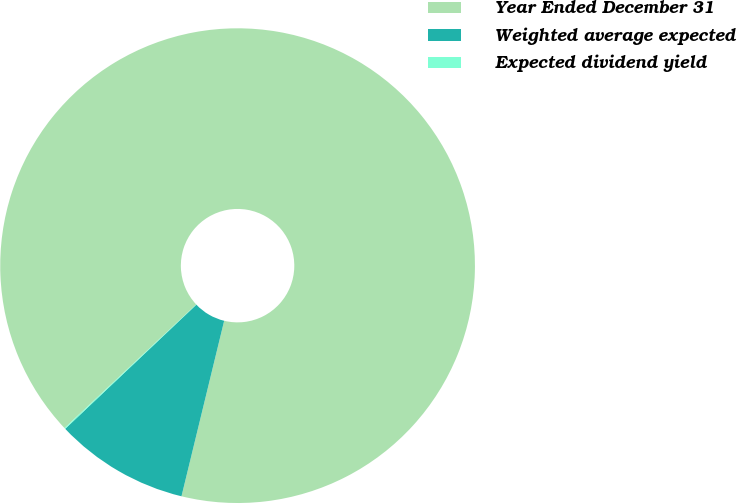Convert chart to OTSL. <chart><loc_0><loc_0><loc_500><loc_500><pie_chart><fcel>Year Ended December 31<fcel>Weighted average expected<fcel>Expected dividend yield<nl><fcel>90.79%<fcel>9.14%<fcel>0.07%<nl></chart> 